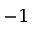Convert formula to latex. <formula><loc_0><loc_0><loc_500><loc_500>- 1</formula> 